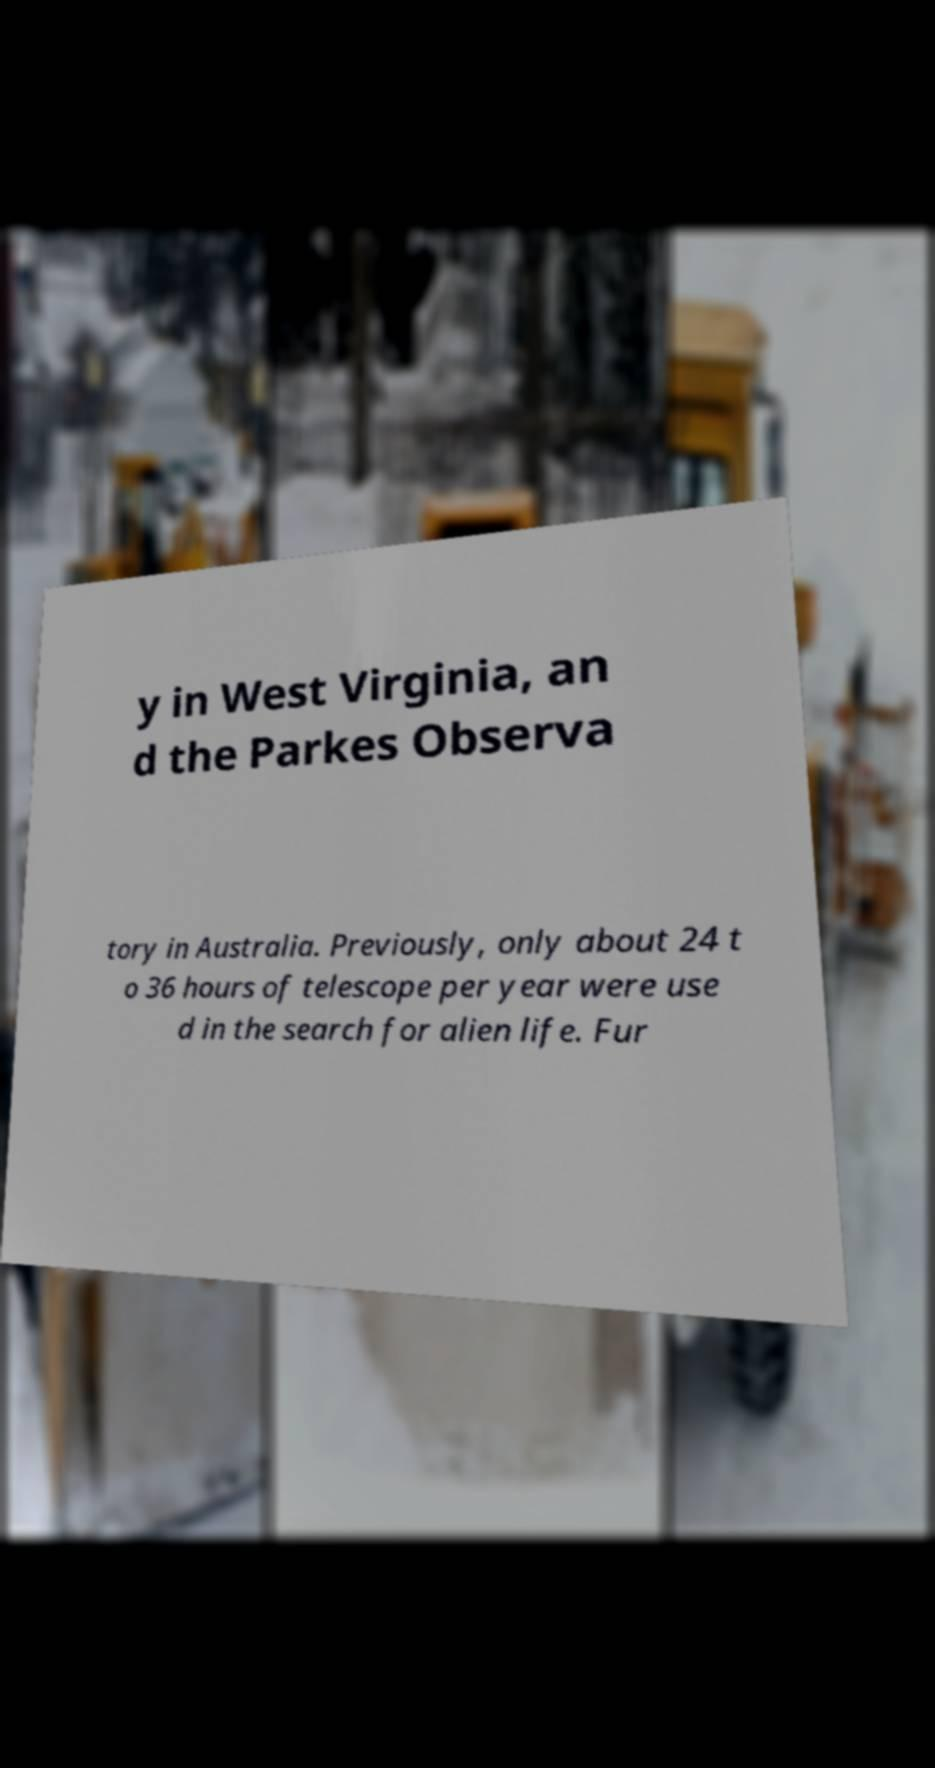What messages or text are displayed in this image? I need them in a readable, typed format. y in West Virginia, an d the Parkes Observa tory in Australia. Previously, only about 24 t o 36 hours of telescope per year were use d in the search for alien life. Fur 